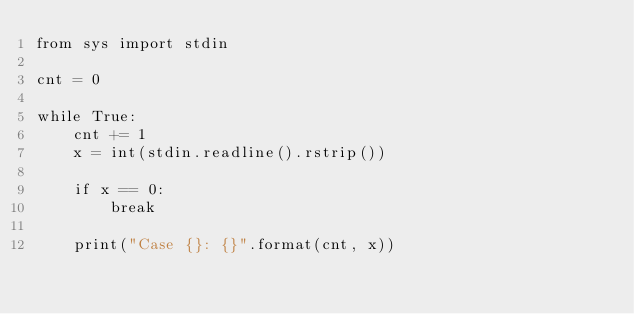Convert code to text. <code><loc_0><loc_0><loc_500><loc_500><_Python_>from sys import stdin

cnt = 0

while True:
    cnt += 1
    x = int(stdin.readline().rstrip())

    if x == 0:
        break

    print("Case {}: {}".format(cnt, x))

</code> 